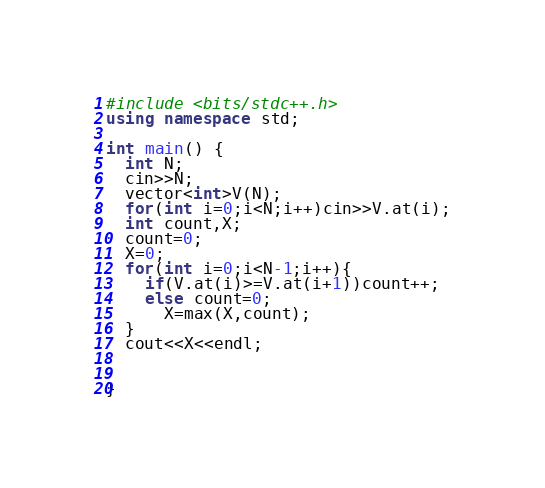Convert code to text. <code><loc_0><loc_0><loc_500><loc_500><_C++_>#include <bits/stdc++.h>
using namespace std;

int main() {
  int N;
  cin>>N;
  vector<int>V(N);
  for(int i=0;i<N;i++)cin>>V.at(i);
  int count,X;
  count=0;
  X=0;
  for(int i=0;i<N-1;i++){
    if(V.at(i)>=V.at(i+1))count++;
    else count=0;
      X=max(X,count);
  }
  cout<<X<<endl;

   
}</code> 